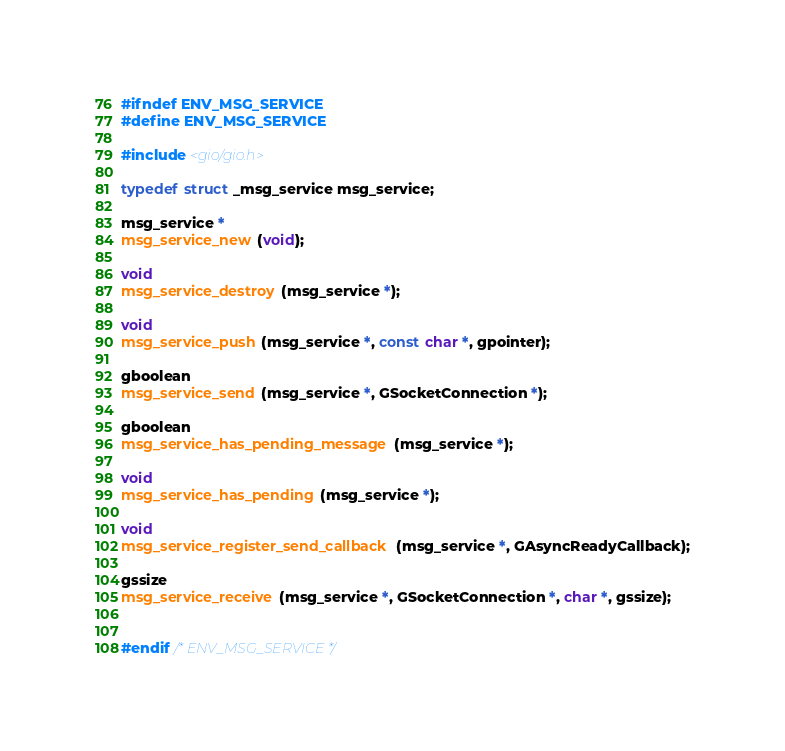<code> <loc_0><loc_0><loc_500><loc_500><_C_>#ifndef ENV_MSG_SERVICE
#define ENV_MSG_SERVICE

#include <gio/gio.h>

typedef struct _msg_service msg_service;

msg_service *
msg_service_new (void);

void
msg_service_destroy (msg_service *);

void
msg_service_push (msg_service *, const char *, gpointer);

gboolean
msg_service_send (msg_service *, GSocketConnection *);

gboolean
msg_service_has_pending_message (msg_service *);

void
msg_service_has_pending (msg_service *);

void
msg_service_register_send_callback (msg_service *, GAsyncReadyCallback);

gssize
msg_service_receive (msg_service *, GSocketConnection *, char *, gssize);


#endif /* ENV_MSG_SERVICE */
</code> 